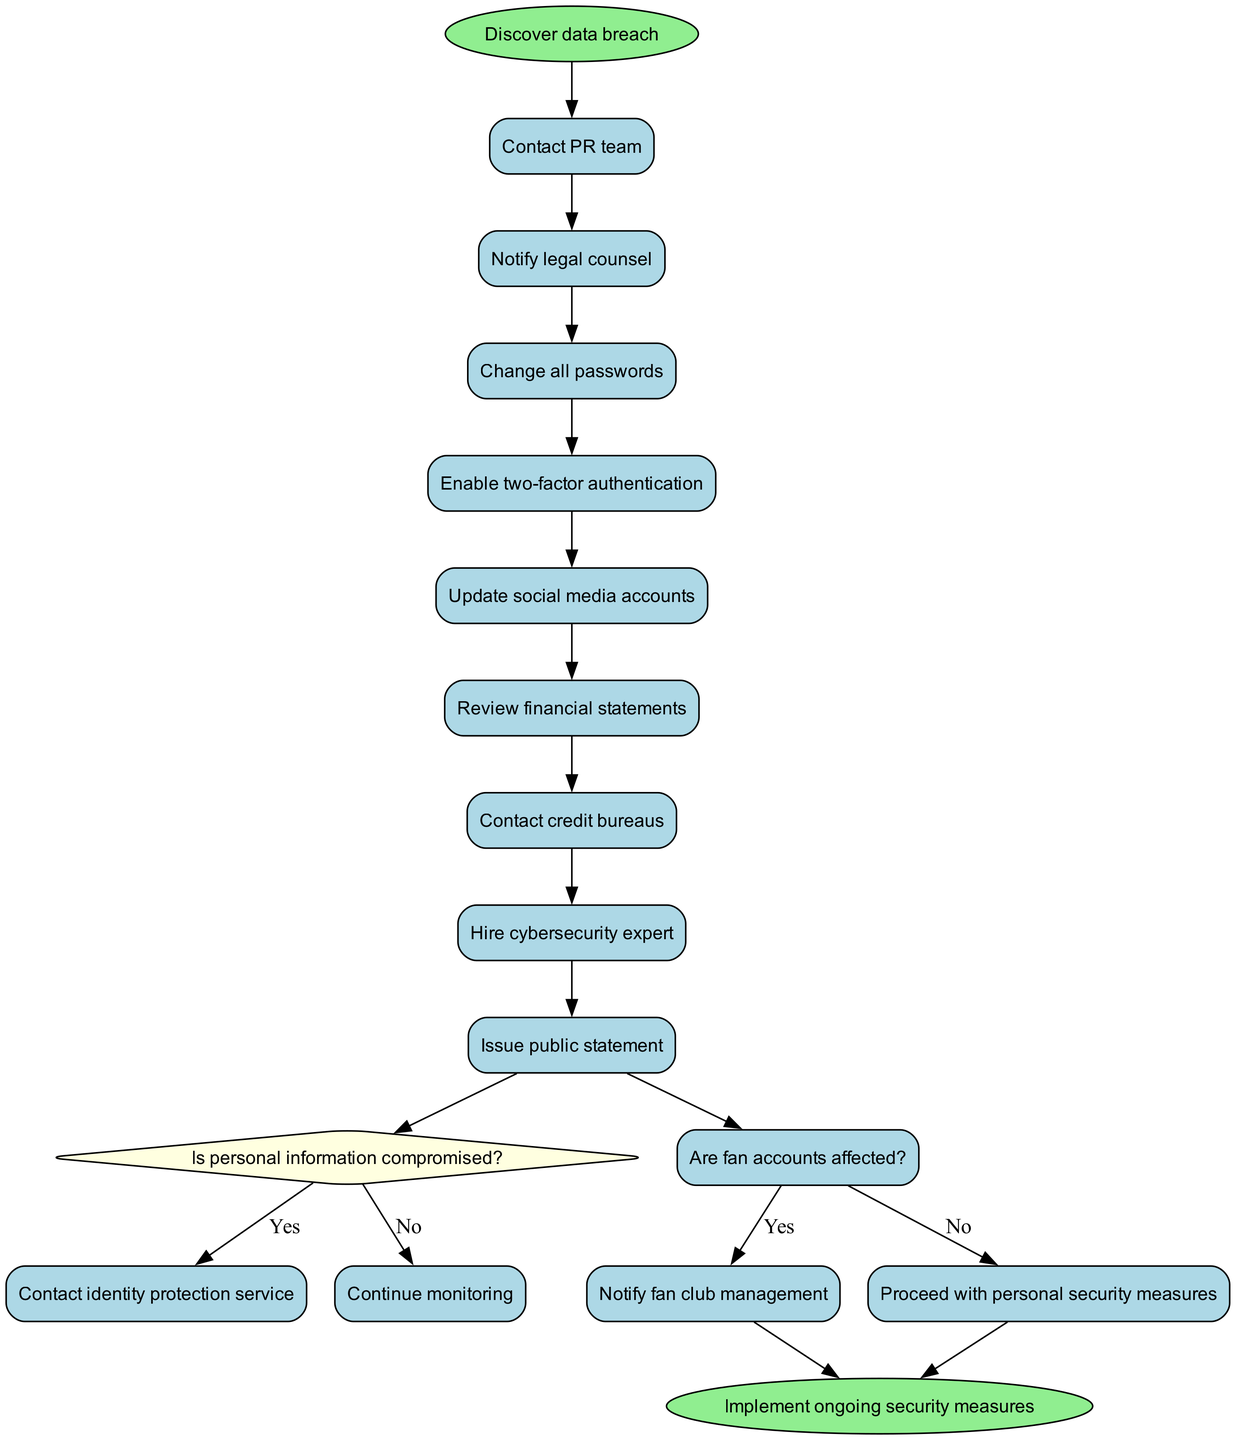What is the starting point of the activity diagram? The starting point, also known as the start node, is labeled as "Discover data breach." This is the initial action that sets the process in motion.
Answer: Discover data breach How many activities are shown in the diagram? The diagram lists a total of eight activities. Upon counting the distinct activities provided, we identify them as different steps in the process.
Answer: 8 What is the last decision node in the diagram? The last decision node in the diagram is the one that asks, "Are fan accounts affected?" This is the final decision point before concluding the activities.
Answer: Are fan accounts affected? Which activity comes immediately after "Notify legal counsel"? The activity that follows "Notify legal counsel" in the sequence is "Change all passwords." This is determined by following the flow of activities in the diagram, where each activity connects to the next.
Answer: Change all passwords If personal information is compromised, what is the next action? If the answer to the question "Is personal information compromised?" is yes, the next action is to "Contact identity protection service." This follows from the decision flow indicated in the diagram.
Answer: Contact identity protection service What is the end node of the process? The end node of the process is labeled "Implement ongoing security measures." This is the final point where all actions lead towards ensuring ongoing security.
Answer: Implement ongoing security measures What is the consequence of the answer "No" to the decision, "Is personal information compromised?" If the answer is "No" to the decision regarding personal information, the flow continues to "Continue monitoring." This indicates a less immediate response to the breach.
Answer: Continue monitoring How many decision points are present in the diagram? The diagram includes two decision points, as indicated by the shapes representing questions that lead to different actions based on the answers.
Answer: 2 